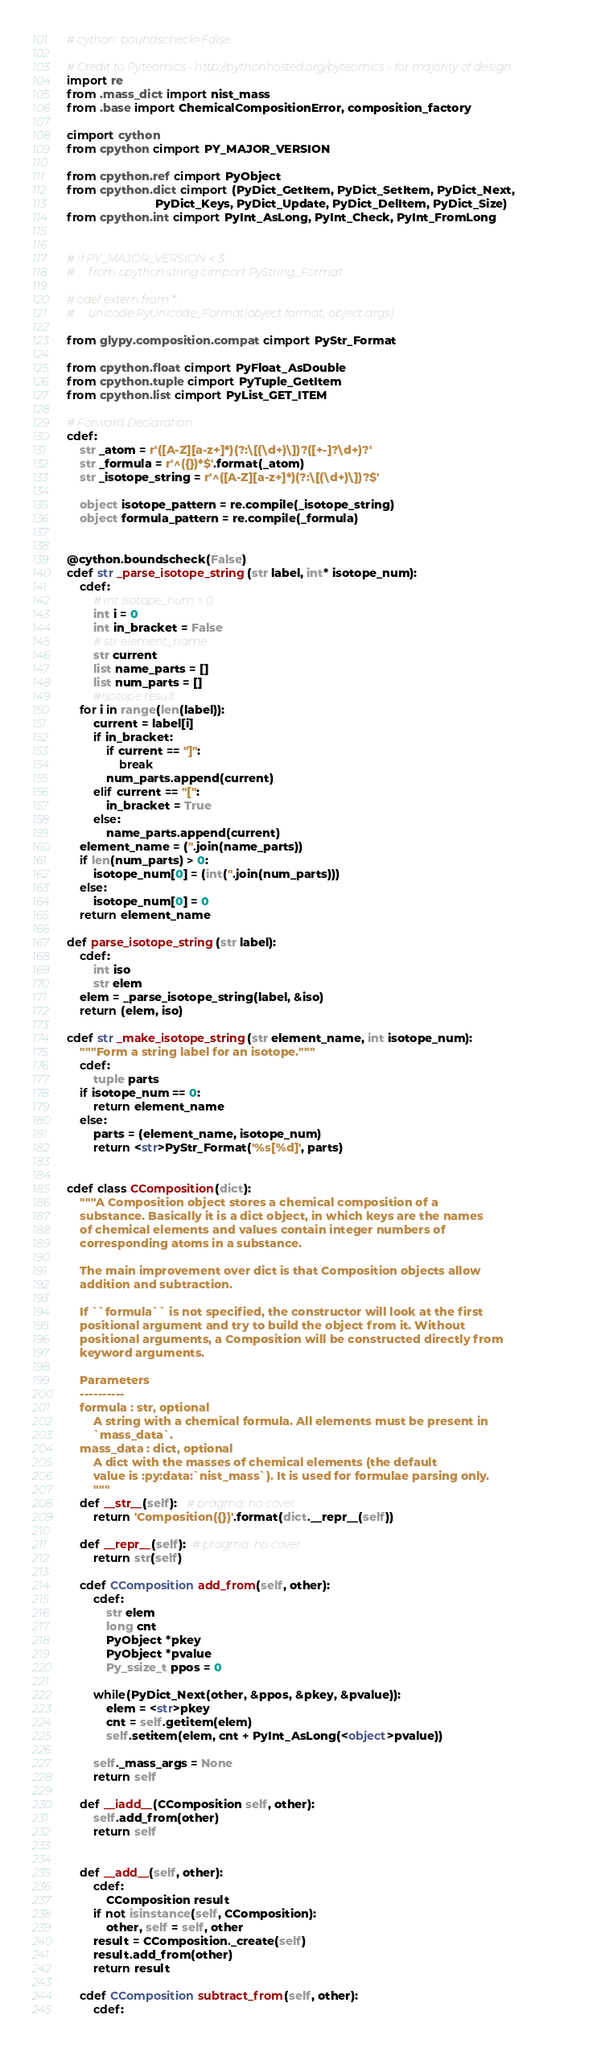<code> <loc_0><loc_0><loc_500><loc_500><_Cython_># cython: boundscheck=False

# Credit to Pyteomics - http://pythonhosted.org/pyteomics - for majority of design
import re
from .mass_dict import nist_mass
from .base import ChemicalCompositionError, composition_factory

cimport cython
from cpython cimport PY_MAJOR_VERSION

from cpython.ref cimport PyObject
from cpython.dict cimport (PyDict_GetItem, PyDict_SetItem, PyDict_Next,
                           PyDict_Keys, PyDict_Update, PyDict_DelItem, PyDict_Size)
from cpython.int cimport PyInt_AsLong, PyInt_Check, PyInt_FromLong


# if PY_MAJOR_VERSION < 3:
#     from cpython.string cimport PyString_Format

# cdef extern from *:
#     unicode PyUnicode_Format(object format, object args)

from glypy.composition.compat cimport PyStr_Format

from cpython.float cimport PyFloat_AsDouble
from cpython.tuple cimport PyTuple_GetItem
from cpython.list cimport PyList_GET_ITEM

# Forward Declaration
cdef: 
    str _atom = r'([A-Z][a-z+]*)(?:\[(\d+)\])?([+-]?\d+)?'
    str _formula = r'^({})*$'.format(_atom)
    str _isotope_string = r'^([A-Z][a-z+]*)(?:\[(\d+)\])?$'

    object isotope_pattern = re.compile(_isotope_string)
    object formula_pattern = re.compile(_formula)


@cython.boundscheck(False)
cdef str _parse_isotope_string(str label, int* isotope_num):
    cdef:
        # int isotope_num = 0
        int i = 0
        int in_bracket = False
        # str element_name
        str current
        list name_parts = []
        list num_parts = []
        #Isotope result
    for i in range(len(label)):
        current = label[i]
        if in_bracket:
            if current == "]":
                break
            num_parts.append(current)
        elif current == "[":
            in_bracket = True
        else:
            name_parts.append(current)
    element_name = (''.join(name_parts))
    if len(num_parts) > 0:
        isotope_num[0] = (int(''.join(num_parts)))
    else:
        isotope_num[0] = 0
    return element_name

def parse_isotope_string(str label):
    cdef:
        int iso
        str elem
    elem = _parse_isotope_string(label, &iso)
    return (elem, iso)

cdef str _make_isotope_string(str element_name, int isotope_num):
    """Form a string label for an isotope."""
    cdef:
        tuple parts
    if isotope_num == 0:
        return element_name
    else:
        parts = (element_name, isotope_num)
        return <str>PyStr_Format('%s[%d]', parts)


cdef class CComposition(dict):
    """A Composition object stores a chemical composition of a
    substance. Basically it is a dict object, in which keys are the names
    of chemical elements and values contain integer numbers of
    corresponding atoms in a substance.

    The main improvement over dict is that Composition objects allow
    addition and subtraction.

    If ``formula`` is not specified, the constructor will look at the first
    positional argument and try to build the object from it. Without
    positional arguments, a Composition will be constructed directly from
    keyword arguments.

    Parameters
    ----------
    formula : str, optional
        A string with a chemical formula. All elements must be present in
        `mass_data`.
    mass_data : dict, optional
        A dict with the masses of chemical elements (the default
        value is :py:data:`nist_mass`). It is used for formulae parsing only.
        """
    def __str__(self):   # pragma: no cover
        return 'Composition({})'.format(dict.__repr__(self))

    def __repr__(self):  # pragma: no cover
        return str(self)

    cdef CComposition add_from(self, other):
        cdef:
            str elem
            long cnt
            PyObject *pkey
            PyObject *pvalue
            Py_ssize_t ppos = 0

        while(PyDict_Next(other, &ppos, &pkey, &pvalue)):
            elem = <str>pkey
            cnt = self.getitem(elem)
            self.setitem(elem, cnt + PyInt_AsLong(<object>pvalue))

        self._mass_args = None
        return self

    def __iadd__(CComposition self, other):
        self.add_from(other)
        return self


    def __add__(self, other):
        cdef:
            CComposition result
        if not isinstance(self, CComposition):
            other, self = self, other
        result = CComposition._create(self)
        result.add_from(other)
        return result

    cdef CComposition subtract_from(self, other):
        cdef:</code> 